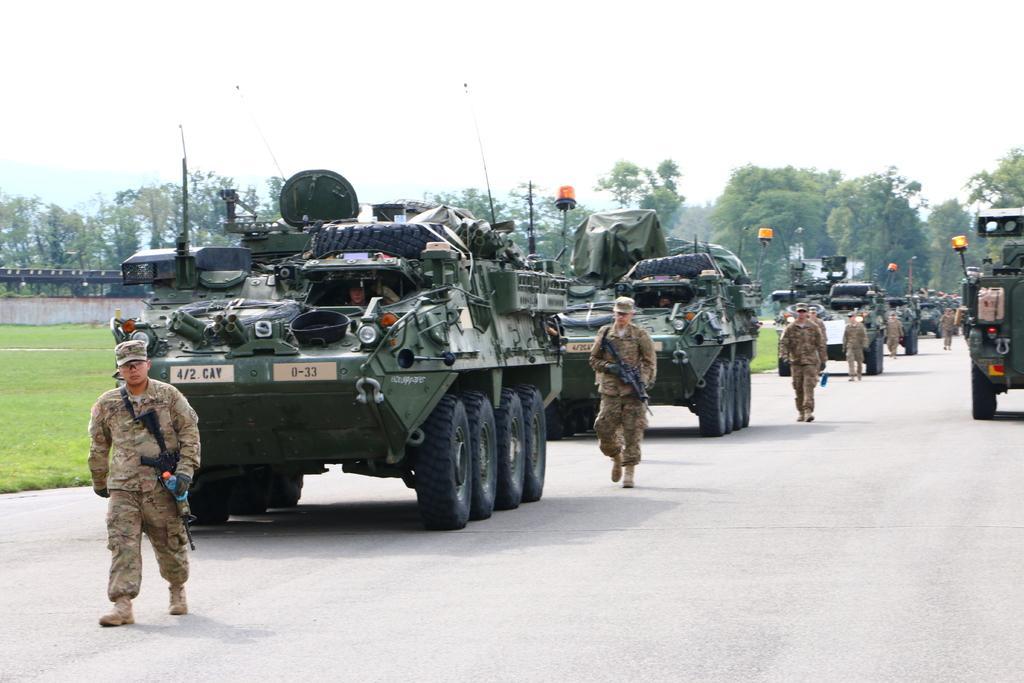Describe this image in one or two sentences. This image consists of few persons walking. And we can see the vehicles in green color. At the bottom, there is a road. On the left, there is green grass on the ground. In the background, there are trees. At the top, there is sky. 